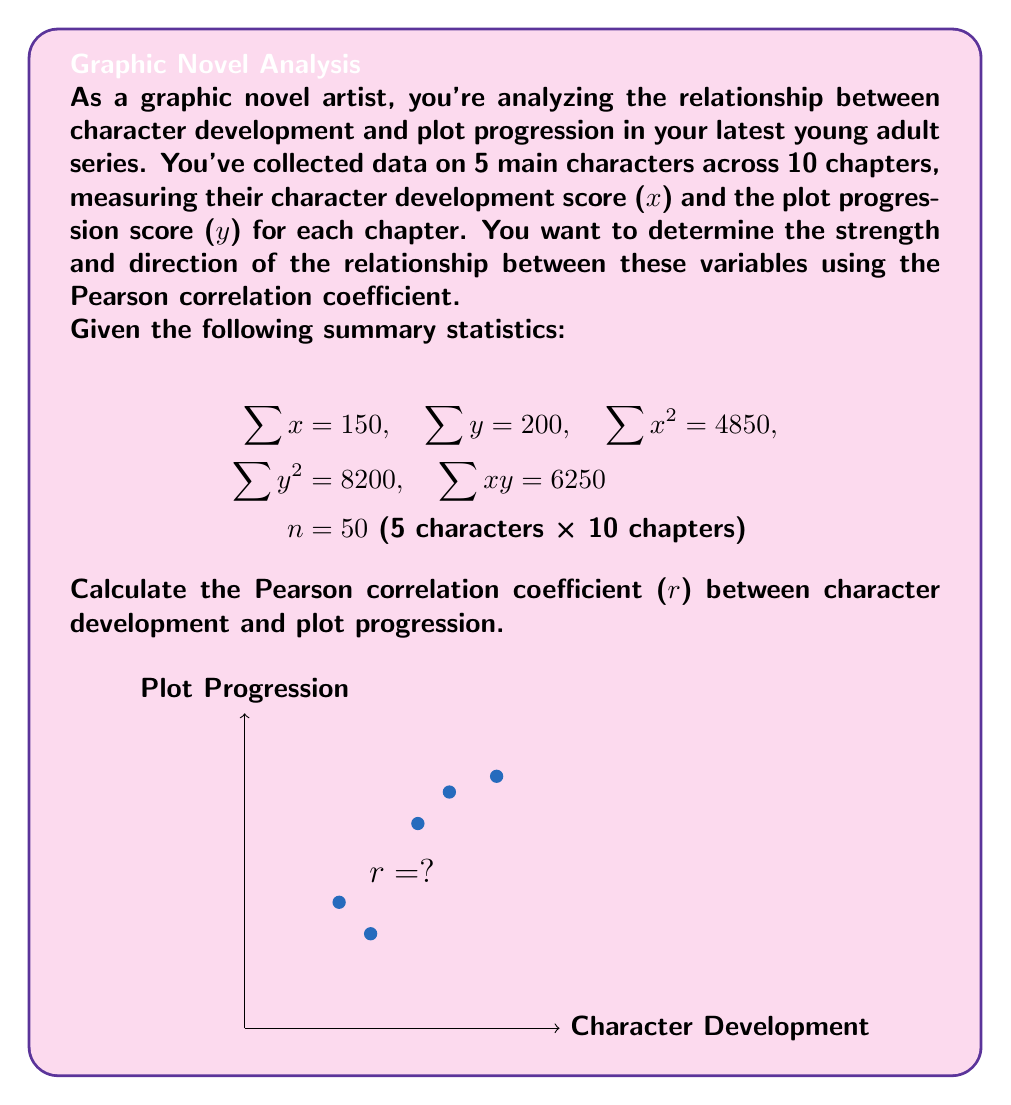Give your solution to this math problem. To calculate the Pearson correlation coefficient (r), we'll use the formula:

$$r = \frac{n\sum xy - \sum x \sum y}{\sqrt{[n\sum x^2 - (\sum x)^2][n\sum y^2 - (\sum y)^2]}}$$

Let's break it down step-by-step:

1. Calculate the means:
   $\bar{x} = \frac{\sum x}{n} = \frac{150}{50} = 3$
   $\bar{y} = \frac{\sum y}{n} = \frac{200}{50} = 4$

2. Calculate $n\sum xy$:
   $n\sum xy = 50 \times 6250 = 312500$

3. Calculate $\sum x \sum y$:
   $\sum x \sum y = 150 \times 200 = 30000$

4. Calculate the numerator:
   $n\sum xy - \sum x \sum y = 312500 - 30000 = 282500$

5. Calculate $n\sum x^2$ and $(\sum x)^2$:
   $n\sum x^2 = 50 \times 4850 = 242500$
   $(\sum x)^2 = 150^2 = 22500$

6. Calculate $n\sum y^2$ and $(\sum y)^2$:
   $n\sum y^2 = 50 \times 8200 = 410000$
   $(\sum y)^2 = 200^2 = 40000$

7. Calculate the denominator:
   $\sqrt{[n\sum x^2 - (\sum x)^2][n\sum y^2 - (\sum y)^2]}$
   $= \sqrt{(242500 - 22500)(410000 - 40000)}$
   $= \sqrt{220000 \times 370000}$
   $= \sqrt{81400000000}$
   $= 285307.55$

8. Finally, calculate r:
   $r = \frac{282500}{285307.55} = 0.9901$

The Pearson correlation coefficient (r) is approximately 0.9901, indicating a very strong positive correlation between character development and plot progression in your graphic novel series.
Answer: $r \approx 0.9901$ 